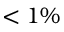<formula> <loc_0><loc_0><loc_500><loc_500>< 1 \%</formula> 